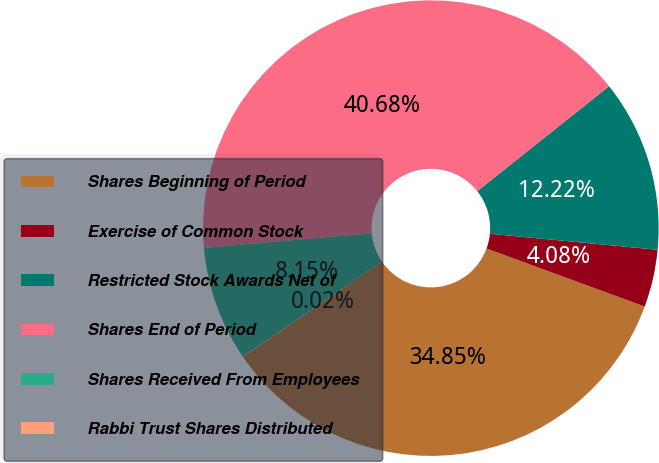Convert chart. <chart><loc_0><loc_0><loc_500><loc_500><pie_chart><fcel>Shares Beginning of Period<fcel>Exercise of Common Stock<fcel>Restricted Stock Awards Net of<fcel>Shares End of Period<fcel>Shares Received From Employees<fcel>Rabbi Trust Shares Distributed<nl><fcel>34.85%<fcel>4.08%<fcel>12.22%<fcel>40.68%<fcel>8.15%<fcel>0.02%<nl></chart> 